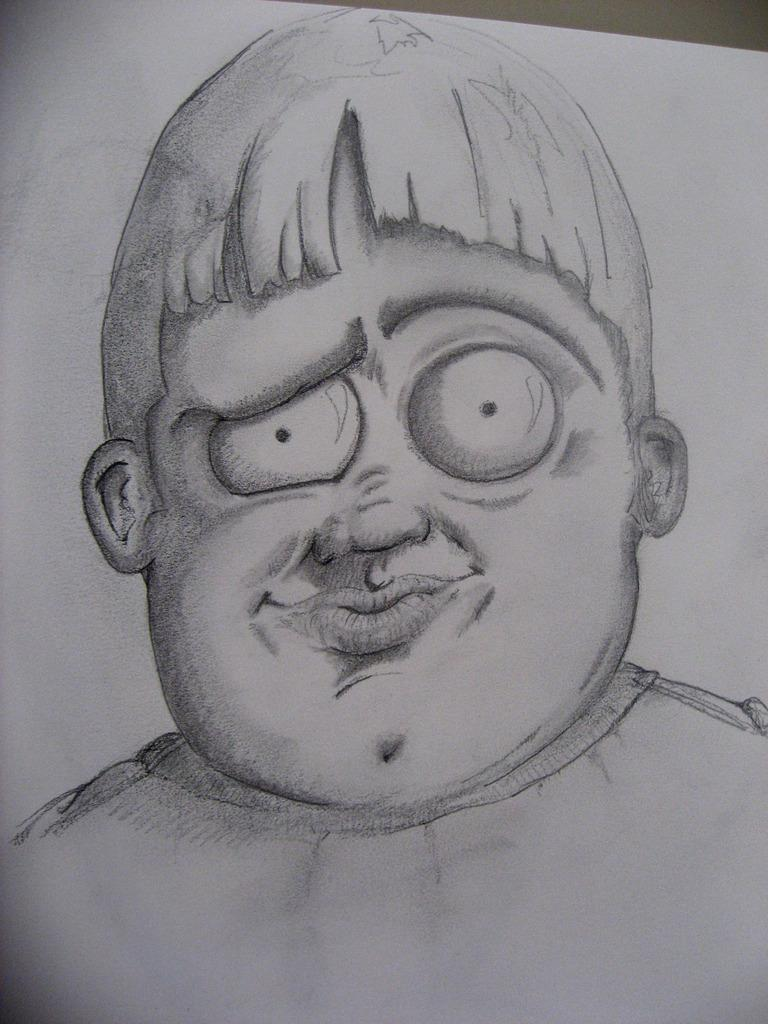What is the main subject of the image? The image contains a painting. What is depicted in the painting? The painting is of a person. What is the color of the paper the painting is on? The paper the painting is on is white. Where is the painting located within the image? The painting is in the middle of the image. What type of wilderness can be seen in the background of the painting? There is no wilderness visible in the painting, as it depicts a person and does not show any background. 